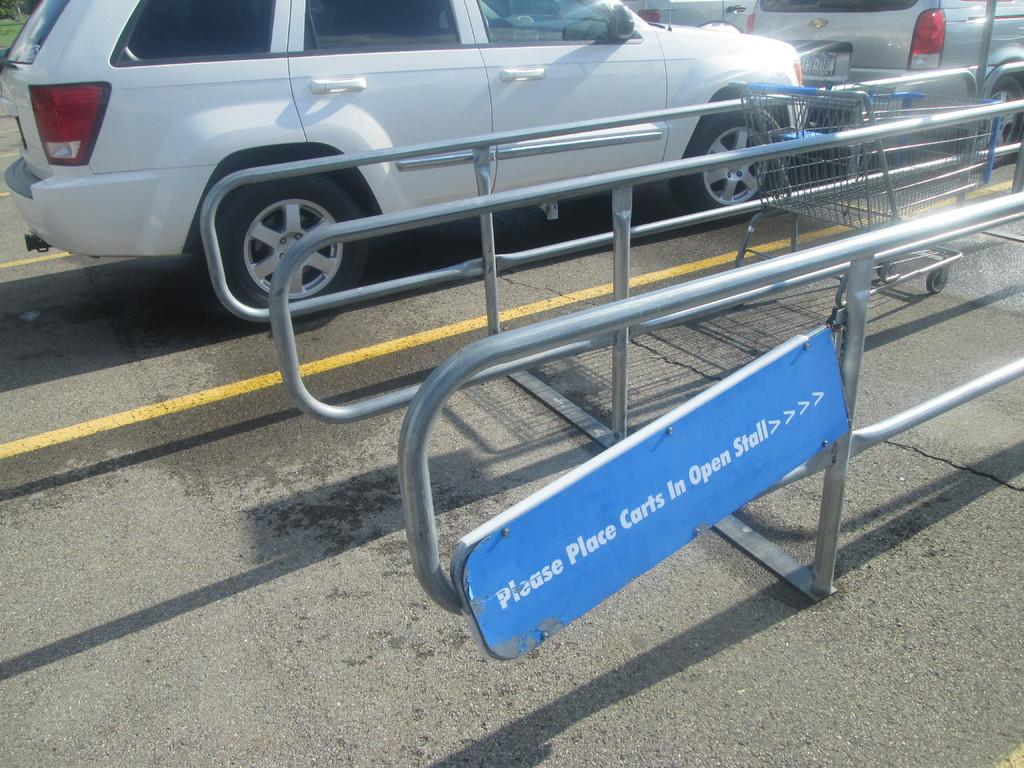What type of surface can be seen in the image? There is a road in the image. What vehicles are present on the road? There are cars in the image. What is the iron stand used for? The purpose of the iron stand is not specified in the image. What type of vegetation is visible in the image? There is grass in the image. What object can be seen on the right side of the image? There is a basket on the right side of the image. How many hands are visible in the image? There are no hands visible in the image. Is there a snake slithering across the road in the image? There is no snake present in the image. 